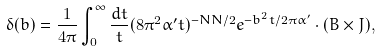Convert formula to latex. <formula><loc_0><loc_0><loc_500><loc_500>\delta ( b ) = \frac { 1 } { 4 \pi } \int _ { 0 } ^ { \infty } \frac { d t } { t } ( 8 \pi ^ { 2 } \alpha ^ { \prime } t ) ^ { - N N / 2 } e ^ { - b ^ { 2 } t / 2 \pi \alpha ^ { \prime } } \cdot ( B \times J ) ,</formula> 